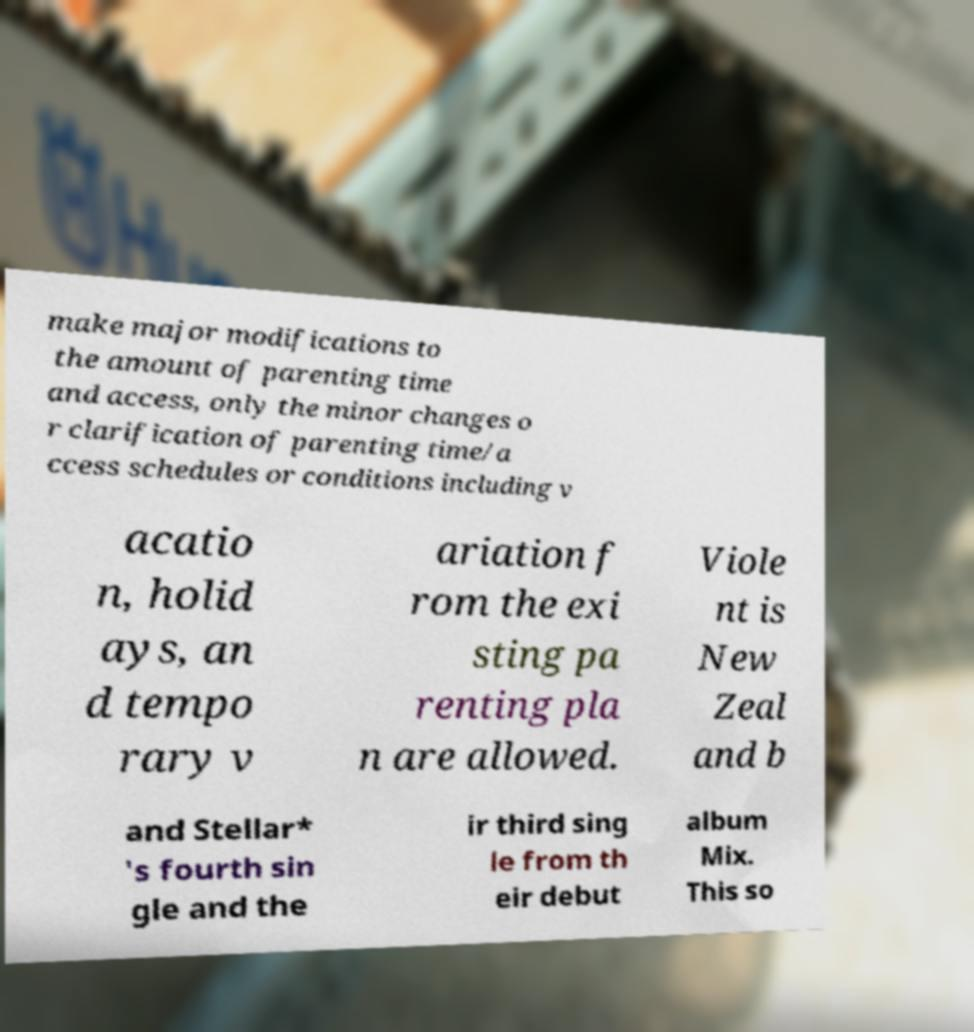Please read and relay the text visible in this image. What does it say? make major modifications to the amount of parenting time and access, only the minor changes o r clarification of parenting time/a ccess schedules or conditions including v acatio n, holid ays, an d tempo rary v ariation f rom the exi sting pa renting pla n are allowed. Viole nt is New Zeal and b and Stellar* 's fourth sin gle and the ir third sing le from th eir debut album Mix. This so 